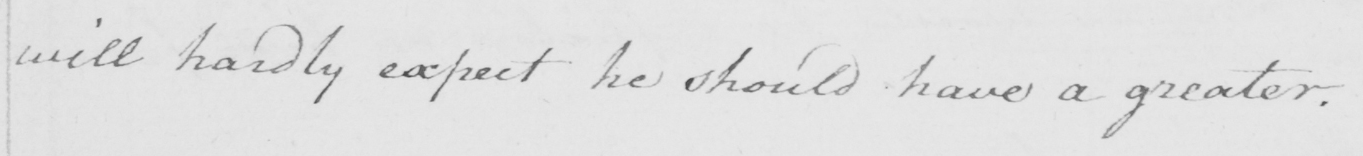Please provide the text content of this handwritten line. will hardly expect he should have a greater . 